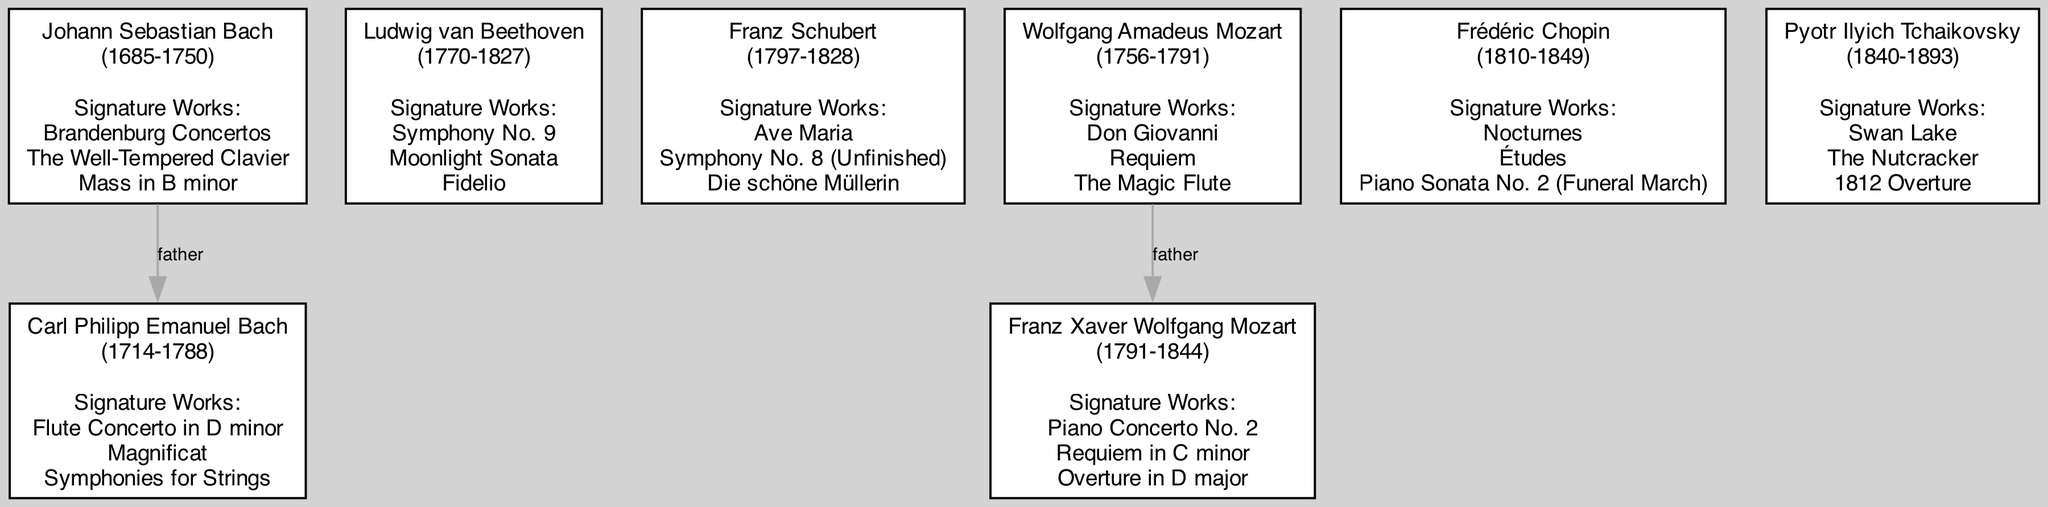What is the signature work of Johann Sebastian Bach that is a collection of concertos? The diagram lists several signature works of Johann Sebastian Bach, and one of his notable works is the "Brandenburg Concertos."
Answer: Brandenburg Concertos How many composers are there in the diagram? By counting all the nodes in the diagram, I find a total of six composers.
Answer: 6 Who is the father of Franz Xaver Wolfgang Mozart? The diagram illustrates a connection labeled "father" between Wolfgang Amadeus Mozart and his son, Franz Xaver Wolfgang Mozart.
Answer: Wolfgang Amadeus Mozart Which composer has "Symphony No. 9" as one of their signature works? The diagram indicates that "Symphony No. 9" is one of the signature works of Ludwig van Beethoven.
Answer: Ludwig van Beethoven What year did Frédéric Chopin die? Looking at the information tied to Frédéric Chopin in the diagram, it states he died in 1849.
Answer: 1849 Which composer is noted as the father of Carl Philipp Emanuel Bach? The diagram shows a direct connection with the label "father" from Johann Sebastian Bach to Carl Philipp Emanuel Bach.
Answer: Johann Sebastian Bach What is one of the signature works of Carl Philipp Emanuel Bach? Within the node for Carl Philipp Emanuel Bach, one of his signature works listed is "Flute Concerto in D minor."
Answer: Flute Concerto in D minor How many works are listed under Wolfgang Amadeus Mozart's signature works? The node for Wolfgang Amadeus Mozart includes three signature works, as noted in the diagram.
Answer: 3 Which composer was born in the year 1810? The diagram specifies that Frédéric Chopin was born in 1810.
Answer: Frédéric Chopin 